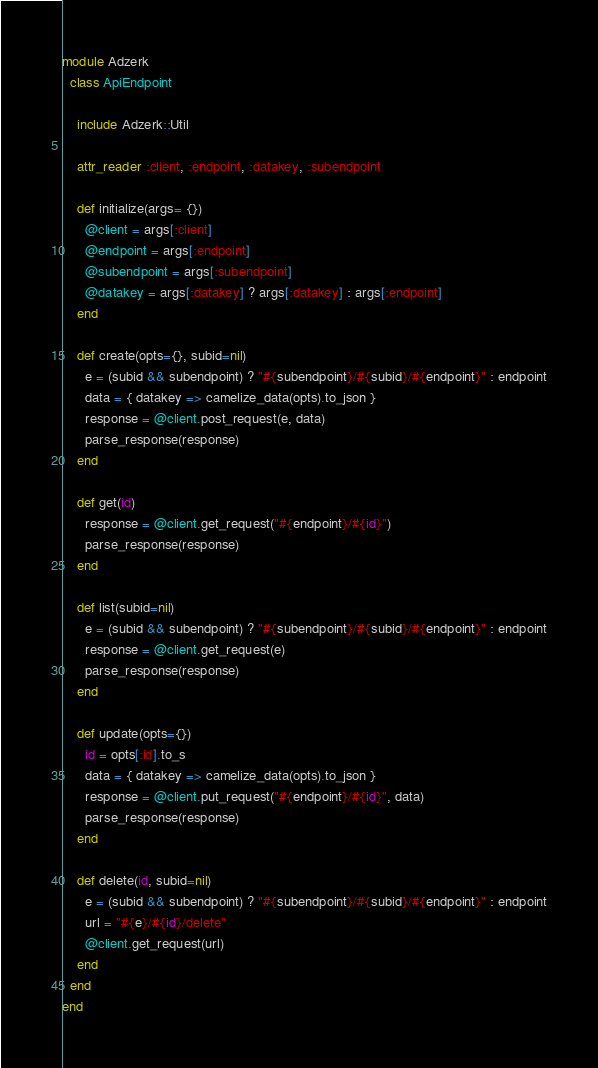Convert code to text. <code><loc_0><loc_0><loc_500><loc_500><_Ruby_>module Adzerk
  class ApiEndpoint

    include Adzerk::Util

    attr_reader :client, :endpoint, :datakey, :subendpoint

    def initialize(args= {})
      @client = args[:client]
      @endpoint = args[:endpoint]
      @subendpoint = args[:subendpoint]
      @datakey = args[:datakey] ? args[:datakey] : args[:endpoint]
    end

    def create(opts={}, subid=nil)
      e = (subid && subendpoint) ? "#{subendpoint}/#{subid}/#{endpoint}" : endpoint
      data = { datakey => camelize_data(opts).to_json }
      response = @client.post_request(e, data)
      parse_response(response)
    end

    def get(id)
      response = @client.get_request("#{endpoint}/#{id}")
      parse_response(response)
    end

    def list(subid=nil)
      e = (subid && subendpoint) ? "#{subendpoint}/#{subid}/#{endpoint}" : endpoint
      response = @client.get_request(e)
      parse_response(response)
    end

    def update(opts={})
      id = opts[:id].to_s
      data = { datakey => camelize_data(opts).to_json }
      response = @client.put_request("#{endpoint}/#{id}", data)
      parse_response(response)
    end

    def delete(id, subid=nil)
      e = (subid && subendpoint) ? "#{subendpoint}/#{subid}/#{endpoint}" : endpoint
      url = "#{e}/#{id}/delete"
      @client.get_request(url)
    end
  end
end
</code> 